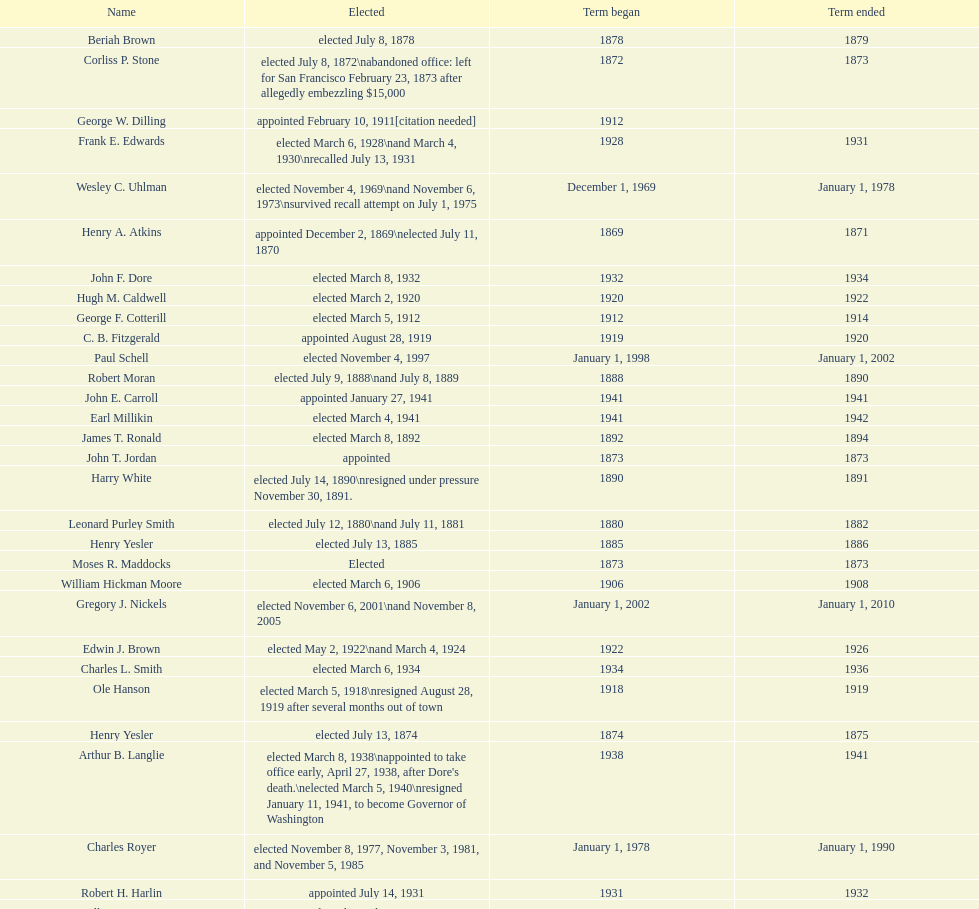Who was the only person elected in 1871? John T. Jordan. 